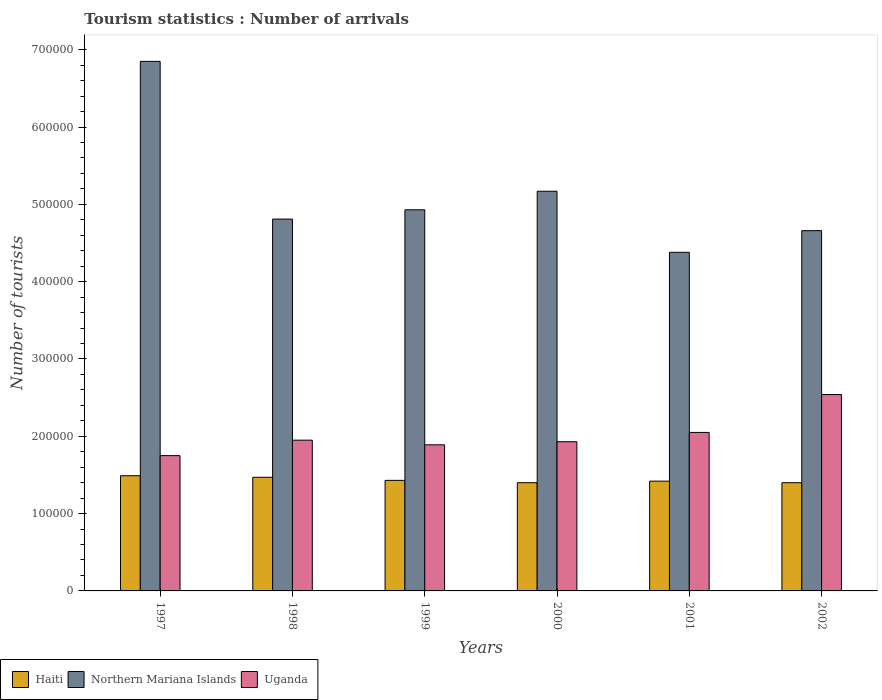How many different coloured bars are there?
Offer a terse response. 3. How many groups of bars are there?
Give a very brief answer. 6. Are the number of bars per tick equal to the number of legend labels?
Keep it short and to the point. Yes. How many bars are there on the 3rd tick from the left?
Ensure brevity in your answer.  3. What is the number of tourist arrivals in Haiti in 2001?
Provide a succinct answer. 1.42e+05. Across all years, what is the maximum number of tourist arrivals in Uganda?
Make the answer very short. 2.54e+05. Across all years, what is the minimum number of tourist arrivals in Northern Mariana Islands?
Your response must be concise. 4.38e+05. In which year was the number of tourist arrivals in Uganda maximum?
Offer a terse response. 2002. In which year was the number of tourist arrivals in Haiti minimum?
Make the answer very short. 2000. What is the total number of tourist arrivals in Haiti in the graph?
Offer a terse response. 8.61e+05. What is the difference between the number of tourist arrivals in Uganda in 1997 and that in 2000?
Ensure brevity in your answer.  -1.80e+04. What is the difference between the number of tourist arrivals in Haiti in 2001 and the number of tourist arrivals in Uganda in 1999?
Give a very brief answer. -4.70e+04. What is the average number of tourist arrivals in Northern Mariana Islands per year?
Your response must be concise. 5.13e+05. In the year 2001, what is the difference between the number of tourist arrivals in Haiti and number of tourist arrivals in Northern Mariana Islands?
Give a very brief answer. -2.96e+05. In how many years, is the number of tourist arrivals in Haiti greater than 40000?
Your answer should be very brief. 6. What is the difference between the highest and the lowest number of tourist arrivals in Haiti?
Make the answer very short. 9000. What does the 2nd bar from the left in 2002 represents?
Give a very brief answer. Northern Mariana Islands. What does the 2nd bar from the right in 2002 represents?
Make the answer very short. Northern Mariana Islands. Is it the case that in every year, the sum of the number of tourist arrivals in Haiti and number of tourist arrivals in Uganda is greater than the number of tourist arrivals in Northern Mariana Islands?
Provide a succinct answer. No. Are the values on the major ticks of Y-axis written in scientific E-notation?
Provide a short and direct response. No. Does the graph contain any zero values?
Keep it short and to the point. No. Does the graph contain grids?
Your answer should be compact. No. Where does the legend appear in the graph?
Give a very brief answer. Bottom left. How many legend labels are there?
Offer a terse response. 3. How are the legend labels stacked?
Keep it short and to the point. Horizontal. What is the title of the graph?
Make the answer very short. Tourism statistics : Number of arrivals. Does "Heavily indebted poor countries" appear as one of the legend labels in the graph?
Offer a terse response. No. What is the label or title of the X-axis?
Ensure brevity in your answer.  Years. What is the label or title of the Y-axis?
Offer a terse response. Number of tourists. What is the Number of tourists of Haiti in 1997?
Your answer should be compact. 1.49e+05. What is the Number of tourists of Northern Mariana Islands in 1997?
Provide a succinct answer. 6.85e+05. What is the Number of tourists of Uganda in 1997?
Keep it short and to the point. 1.75e+05. What is the Number of tourists in Haiti in 1998?
Give a very brief answer. 1.47e+05. What is the Number of tourists of Northern Mariana Islands in 1998?
Your answer should be very brief. 4.81e+05. What is the Number of tourists in Uganda in 1998?
Offer a terse response. 1.95e+05. What is the Number of tourists in Haiti in 1999?
Keep it short and to the point. 1.43e+05. What is the Number of tourists of Northern Mariana Islands in 1999?
Make the answer very short. 4.93e+05. What is the Number of tourists in Uganda in 1999?
Offer a terse response. 1.89e+05. What is the Number of tourists in Northern Mariana Islands in 2000?
Keep it short and to the point. 5.17e+05. What is the Number of tourists of Uganda in 2000?
Give a very brief answer. 1.93e+05. What is the Number of tourists of Haiti in 2001?
Offer a very short reply. 1.42e+05. What is the Number of tourists of Northern Mariana Islands in 2001?
Provide a succinct answer. 4.38e+05. What is the Number of tourists of Uganda in 2001?
Ensure brevity in your answer.  2.05e+05. What is the Number of tourists in Haiti in 2002?
Your response must be concise. 1.40e+05. What is the Number of tourists in Northern Mariana Islands in 2002?
Offer a very short reply. 4.66e+05. What is the Number of tourists in Uganda in 2002?
Ensure brevity in your answer.  2.54e+05. Across all years, what is the maximum Number of tourists in Haiti?
Offer a terse response. 1.49e+05. Across all years, what is the maximum Number of tourists in Northern Mariana Islands?
Your response must be concise. 6.85e+05. Across all years, what is the maximum Number of tourists of Uganda?
Your answer should be compact. 2.54e+05. Across all years, what is the minimum Number of tourists in Northern Mariana Islands?
Keep it short and to the point. 4.38e+05. Across all years, what is the minimum Number of tourists of Uganda?
Provide a short and direct response. 1.75e+05. What is the total Number of tourists of Haiti in the graph?
Give a very brief answer. 8.61e+05. What is the total Number of tourists of Northern Mariana Islands in the graph?
Give a very brief answer. 3.08e+06. What is the total Number of tourists of Uganda in the graph?
Make the answer very short. 1.21e+06. What is the difference between the Number of tourists of Northern Mariana Islands in 1997 and that in 1998?
Provide a succinct answer. 2.04e+05. What is the difference between the Number of tourists of Haiti in 1997 and that in 1999?
Keep it short and to the point. 6000. What is the difference between the Number of tourists in Northern Mariana Islands in 1997 and that in 1999?
Ensure brevity in your answer.  1.92e+05. What is the difference between the Number of tourists of Uganda in 1997 and that in 1999?
Make the answer very short. -1.40e+04. What is the difference between the Number of tourists of Haiti in 1997 and that in 2000?
Offer a very short reply. 9000. What is the difference between the Number of tourists of Northern Mariana Islands in 1997 and that in 2000?
Make the answer very short. 1.68e+05. What is the difference between the Number of tourists of Uganda in 1997 and that in 2000?
Offer a terse response. -1.80e+04. What is the difference between the Number of tourists of Haiti in 1997 and that in 2001?
Your answer should be very brief. 7000. What is the difference between the Number of tourists in Northern Mariana Islands in 1997 and that in 2001?
Offer a terse response. 2.47e+05. What is the difference between the Number of tourists in Uganda in 1997 and that in 2001?
Provide a succinct answer. -3.00e+04. What is the difference between the Number of tourists of Haiti in 1997 and that in 2002?
Provide a succinct answer. 9000. What is the difference between the Number of tourists in Northern Mariana Islands in 1997 and that in 2002?
Give a very brief answer. 2.19e+05. What is the difference between the Number of tourists in Uganda in 1997 and that in 2002?
Offer a very short reply. -7.90e+04. What is the difference between the Number of tourists in Haiti in 1998 and that in 1999?
Your answer should be compact. 4000. What is the difference between the Number of tourists in Northern Mariana Islands in 1998 and that in 1999?
Give a very brief answer. -1.20e+04. What is the difference between the Number of tourists of Uganda in 1998 and that in 1999?
Keep it short and to the point. 6000. What is the difference between the Number of tourists of Haiti in 1998 and that in 2000?
Offer a very short reply. 7000. What is the difference between the Number of tourists of Northern Mariana Islands in 1998 and that in 2000?
Provide a succinct answer. -3.60e+04. What is the difference between the Number of tourists in Uganda in 1998 and that in 2000?
Provide a short and direct response. 2000. What is the difference between the Number of tourists of Haiti in 1998 and that in 2001?
Provide a short and direct response. 5000. What is the difference between the Number of tourists in Northern Mariana Islands in 1998 and that in 2001?
Keep it short and to the point. 4.30e+04. What is the difference between the Number of tourists in Uganda in 1998 and that in 2001?
Ensure brevity in your answer.  -10000. What is the difference between the Number of tourists in Haiti in 1998 and that in 2002?
Provide a succinct answer. 7000. What is the difference between the Number of tourists in Northern Mariana Islands in 1998 and that in 2002?
Provide a succinct answer. 1.50e+04. What is the difference between the Number of tourists of Uganda in 1998 and that in 2002?
Ensure brevity in your answer.  -5.90e+04. What is the difference between the Number of tourists of Haiti in 1999 and that in 2000?
Your response must be concise. 3000. What is the difference between the Number of tourists in Northern Mariana Islands in 1999 and that in 2000?
Your answer should be very brief. -2.40e+04. What is the difference between the Number of tourists in Uganda in 1999 and that in 2000?
Your response must be concise. -4000. What is the difference between the Number of tourists in Haiti in 1999 and that in 2001?
Ensure brevity in your answer.  1000. What is the difference between the Number of tourists of Northern Mariana Islands in 1999 and that in 2001?
Ensure brevity in your answer.  5.50e+04. What is the difference between the Number of tourists in Uganda in 1999 and that in 2001?
Offer a very short reply. -1.60e+04. What is the difference between the Number of tourists in Haiti in 1999 and that in 2002?
Offer a terse response. 3000. What is the difference between the Number of tourists of Northern Mariana Islands in 1999 and that in 2002?
Provide a succinct answer. 2.70e+04. What is the difference between the Number of tourists of Uganda in 1999 and that in 2002?
Your response must be concise. -6.50e+04. What is the difference between the Number of tourists in Haiti in 2000 and that in 2001?
Keep it short and to the point. -2000. What is the difference between the Number of tourists of Northern Mariana Islands in 2000 and that in 2001?
Your answer should be very brief. 7.90e+04. What is the difference between the Number of tourists of Uganda in 2000 and that in 2001?
Ensure brevity in your answer.  -1.20e+04. What is the difference between the Number of tourists in Northern Mariana Islands in 2000 and that in 2002?
Provide a short and direct response. 5.10e+04. What is the difference between the Number of tourists of Uganda in 2000 and that in 2002?
Offer a terse response. -6.10e+04. What is the difference between the Number of tourists of Northern Mariana Islands in 2001 and that in 2002?
Ensure brevity in your answer.  -2.80e+04. What is the difference between the Number of tourists in Uganda in 2001 and that in 2002?
Ensure brevity in your answer.  -4.90e+04. What is the difference between the Number of tourists of Haiti in 1997 and the Number of tourists of Northern Mariana Islands in 1998?
Your answer should be compact. -3.32e+05. What is the difference between the Number of tourists in Haiti in 1997 and the Number of tourists in Uganda in 1998?
Offer a terse response. -4.60e+04. What is the difference between the Number of tourists in Northern Mariana Islands in 1997 and the Number of tourists in Uganda in 1998?
Offer a very short reply. 4.90e+05. What is the difference between the Number of tourists in Haiti in 1997 and the Number of tourists in Northern Mariana Islands in 1999?
Your answer should be compact. -3.44e+05. What is the difference between the Number of tourists in Haiti in 1997 and the Number of tourists in Uganda in 1999?
Make the answer very short. -4.00e+04. What is the difference between the Number of tourists in Northern Mariana Islands in 1997 and the Number of tourists in Uganda in 1999?
Your answer should be compact. 4.96e+05. What is the difference between the Number of tourists in Haiti in 1997 and the Number of tourists in Northern Mariana Islands in 2000?
Your response must be concise. -3.68e+05. What is the difference between the Number of tourists of Haiti in 1997 and the Number of tourists of Uganda in 2000?
Ensure brevity in your answer.  -4.40e+04. What is the difference between the Number of tourists in Northern Mariana Islands in 1997 and the Number of tourists in Uganda in 2000?
Your response must be concise. 4.92e+05. What is the difference between the Number of tourists in Haiti in 1997 and the Number of tourists in Northern Mariana Islands in 2001?
Ensure brevity in your answer.  -2.89e+05. What is the difference between the Number of tourists of Haiti in 1997 and the Number of tourists of Uganda in 2001?
Make the answer very short. -5.60e+04. What is the difference between the Number of tourists in Haiti in 1997 and the Number of tourists in Northern Mariana Islands in 2002?
Provide a succinct answer. -3.17e+05. What is the difference between the Number of tourists in Haiti in 1997 and the Number of tourists in Uganda in 2002?
Your answer should be very brief. -1.05e+05. What is the difference between the Number of tourists in Northern Mariana Islands in 1997 and the Number of tourists in Uganda in 2002?
Your answer should be compact. 4.31e+05. What is the difference between the Number of tourists in Haiti in 1998 and the Number of tourists in Northern Mariana Islands in 1999?
Provide a short and direct response. -3.46e+05. What is the difference between the Number of tourists of Haiti in 1998 and the Number of tourists of Uganda in 1999?
Your response must be concise. -4.20e+04. What is the difference between the Number of tourists in Northern Mariana Islands in 1998 and the Number of tourists in Uganda in 1999?
Provide a short and direct response. 2.92e+05. What is the difference between the Number of tourists of Haiti in 1998 and the Number of tourists of Northern Mariana Islands in 2000?
Give a very brief answer. -3.70e+05. What is the difference between the Number of tourists of Haiti in 1998 and the Number of tourists of Uganda in 2000?
Your answer should be very brief. -4.60e+04. What is the difference between the Number of tourists of Northern Mariana Islands in 1998 and the Number of tourists of Uganda in 2000?
Your answer should be compact. 2.88e+05. What is the difference between the Number of tourists in Haiti in 1998 and the Number of tourists in Northern Mariana Islands in 2001?
Give a very brief answer. -2.91e+05. What is the difference between the Number of tourists in Haiti in 1998 and the Number of tourists in Uganda in 2001?
Provide a short and direct response. -5.80e+04. What is the difference between the Number of tourists in Northern Mariana Islands in 1998 and the Number of tourists in Uganda in 2001?
Offer a very short reply. 2.76e+05. What is the difference between the Number of tourists in Haiti in 1998 and the Number of tourists in Northern Mariana Islands in 2002?
Make the answer very short. -3.19e+05. What is the difference between the Number of tourists of Haiti in 1998 and the Number of tourists of Uganda in 2002?
Your response must be concise. -1.07e+05. What is the difference between the Number of tourists in Northern Mariana Islands in 1998 and the Number of tourists in Uganda in 2002?
Your answer should be very brief. 2.27e+05. What is the difference between the Number of tourists of Haiti in 1999 and the Number of tourists of Northern Mariana Islands in 2000?
Ensure brevity in your answer.  -3.74e+05. What is the difference between the Number of tourists of Haiti in 1999 and the Number of tourists of Uganda in 2000?
Your answer should be compact. -5.00e+04. What is the difference between the Number of tourists in Northern Mariana Islands in 1999 and the Number of tourists in Uganda in 2000?
Provide a succinct answer. 3.00e+05. What is the difference between the Number of tourists of Haiti in 1999 and the Number of tourists of Northern Mariana Islands in 2001?
Your answer should be very brief. -2.95e+05. What is the difference between the Number of tourists of Haiti in 1999 and the Number of tourists of Uganda in 2001?
Give a very brief answer. -6.20e+04. What is the difference between the Number of tourists in Northern Mariana Islands in 1999 and the Number of tourists in Uganda in 2001?
Keep it short and to the point. 2.88e+05. What is the difference between the Number of tourists of Haiti in 1999 and the Number of tourists of Northern Mariana Islands in 2002?
Ensure brevity in your answer.  -3.23e+05. What is the difference between the Number of tourists in Haiti in 1999 and the Number of tourists in Uganda in 2002?
Offer a terse response. -1.11e+05. What is the difference between the Number of tourists of Northern Mariana Islands in 1999 and the Number of tourists of Uganda in 2002?
Give a very brief answer. 2.39e+05. What is the difference between the Number of tourists of Haiti in 2000 and the Number of tourists of Northern Mariana Islands in 2001?
Keep it short and to the point. -2.98e+05. What is the difference between the Number of tourists in Haiti in 2000 and the Number of tourists in Uganda in 2001?
Offer a terse response. -6.50e+04. What is the difference between the Number of tourists of Northern Mariana Islands in 2000 and the Number of tourists of Uganda in 2001?
Ensure brevity in your answer.  3.12e+05. What is the difference between the Number of tourists of Haiti in 2000 and the Number of tourists of Northern Mariana Islands in 2002?
Offer a terse response. -3.26e+05. What is the difference between the Number of tourists in Haiti in 2000 and the Number of tourists in Uganda in 2002?
Keep it short and to the point. -1.14e+05. What is the difference between the Number of tourists of Northern Mariana Islands in 2000 and the Number of tourists of Uganda in 2002?
Provide a succinct answer. 2.63e+05. What is the difference between the Number of tourists in Haiti in 2001 and the Number of tourists in Northern Mariana Islands in 2002?
Provide a short and direct response. -3.24e+05. What is the difference between the Number of tourists of Haiti in 2001 and the Number of tourists of Uganda in 2002?
Your answer should be very brief. -1.12e+05. What is the difference between the Number of tourists in Northern Mariana Islands in 2001 and the Number of tourists in Uganda in 2002?
Keep it short and to the point. 1.84e+05. What is the average Number of tourists in Haiti per year?
Provide a succinct answer. 1.44e+05. What is the average Number of tourists in Northern Mariana Islands per year?
Provide a short and direct response. 5.13e+05. What is the average Number of tourists of Uganda per year?
Keep it short and to the point. 2.02e+05. In the year 1997, what is the difference between the Number of tourists in Haiti and Number of tourists in Northern Mariana Islands?
Keep it short and to the point. -5.36e+05. In the year 1997, what is the difference between the Number of tourists of Haiti and Number of tourists of Uganda?
Provide a succinct answer. -2.60e+04. In the year 1997, what is the difference between the Number of tourists of Northern Mariana Islands and Number of tourists of Uganda?
Offer a terse response. 5.10e+05. In the year 1998, what is the difference between the Number of tourists in Haiti and Number of tourists in Northern Mariana Islands?
Keep it short and to the point. -3.34e+05. In the year 1998, what is the difference between the Number of tourists of Haiti and Number of tourists of Uganda?
Make the answer very short. -4.80e+04. In the year 1998, what is the difference between the Number of tourists in Northern Mariana Islands and Number of tourists in Uganda?
Your answer should be very brief. 2.86e+05. In the year 1999, what is the difference between the Number of tourists of Haiti and Number of tourists of Northern Mariana Islands?
Provide a succinct answer. -3.50e+05. In the year 1999, what is the difference between the Number of tourists in Haiti and Number of tourists in Uganda?
Give a very brief answer. -4.60e+04. In the year 1999, what is the difference between the Number of tourists of Northern Mariana Islands and Number of tourists of Uganda?
Ensure brevity in your answer.  3.04e+05. In the year 2000, what is the difference between the Number of tourists in Haiti and Number of tourists in Northern Mariana Islands?
Provide a short and direct response. -3.77e+05. In the year 2000, what is the difference between the Number of tourists in Haiti and Number of tourists in Uganda?
Your answer should be very brief. -5.30e+04. In the year 2000, what is the difference between the Number of tourists of Northern Mariana Islands and Number of tourists of Uganda?
Your response must be concise. 3.24e+05. In the year 2001, what is the difference between the Number of tourists of Haiti and Number of tourists of Northern Mariana Islands?
Give a very brief answer. -2.96e+05. In the year 2001, what is the difference between the Number of tourists in Haiti and Number of tourists in Uganda?
Offer a terse response. -6.30e+04. In the year 2001, what is the difference between the Number of tourists of Northern Mariana Islands and Number of tourists of Uganda?
Your answer should be compact. 2.33e+05. In the year 2002, what is the difference between the Number of tourists of Haiti and Number of tourists of Northern Mariana Islands?
Your answer should be compact. -3.26e+05. In the year 2002, what is the difference between the Number of tourists in Haiti and Number of tourists in Uganda?
Give a very brief answer. -1.14e+05. In the year 2002, what is the difference between the Number of tourists in Northern Mariana Islands and Number of tourists in Uganda?
Provide a succinct answer. 2.12e+05. What is the ratio of the Number of tourists in Haiti in 1997 to that in 1998?
Offer a very short reply. 1.01. What is the ratio of the Number of tourists of Northern Mariana Islands in 1997 to that in 1998?
Your answer should be very brief. 1.42. What is the ratio of the Number of tourists in Uganda in 1997 to that in 1998?
Provide a short and direct response. 0.9. What is the ratio of the Number of tourists of Haiti in 1997 to that in 1999?
Keep it short and to the point. 1.04. What is the ratio of the Number of tourists of Northern Mariana Islands in 1997 to that in 1999?
Provide a short and direct response. 1.39. What is the ratio of the Number of tourists of Uganda in 1997 to that in 1999?
Your response must be concise. 0.93. What is the ratio of the Number of tourists in Haiti in 1997 to that in 2000?
Your answer should be compact. 1.06. What is the ratio of the Number of tourists of Northern Mariana Islands in 1997 to that in 2000?
Offer a terse response. 1.32. What is the ratio of the Number of tourists of Uganda in 1997 to that in 2000?
Your answer should be very brief. 0.91. What is the ratio of the Number of tourists of Haiti in 1997 to that in 2001?
Offer a very short reply. 1.05. What is the ratio of the Number of tourists in Northern Mariana Islands in 1997 to that in 2001?
Provide a short and direct response. 1.56. What is the ratio of the Number of tourists in Uganda in 1997 to that in 2001?
Your response must be concise. 0.85. What is the ratio of the Number of tourists of Haiti in 1997 to that in 2002?
Your answer should be compact. 1.06. What is the ratio of the Number of tourists in Northern Mariana Islands in 1997 to that in 2002?
Your response must be concise. 1.47. What is the ratio of the Number of tourists of Uganda in 1997 to that in 2002?
Ensure brevity in your answer.  0.69. What is the ratio of the Number of tourists of Haiti in 1998 to that in 1999?
Ensure brevity in your answer.  1.03. What is the ratio of the Number of tourists in Northern Mariana Islands in 1998 to that in 1999?
Provide a short and direct response. 0.98. What is the ratio of the Number of tourists in Uganda in 1998 to that in 1999?
Make the answer very short. 1.03. What is the ratio of the Number of tourists in Northern Mariana Islands in 1998 to that in 2000?
Your answer should be compact. 0.93. What is the ratio of the Number of tourists in Uganda in 1998 to that in 2000?
Your response must be concise. 1.01. What is the ratio of the Number of tourists in Haiti in 1998 to that in 2001?
Offer a very short reply. 1.04. What is the ratio of the Number of tourists in Northern Mariana Islands in 1998 to that in 2001?
Ensure brevity in your answer.  1.1. What is the ratio of the Number of tourists of Uganda in 1998 to that in 2001?
Provide a succinct answer. 0.95. What is the ratio of the Number of tourists in Northern Mariana Islands in 1998 to that in 2002?
Offer a very short reply. 1.03. What is the ratio of the Number of tourists of Uganda in 1998 to that in 2002?
Ensure brevity in your answer.  0.77. What is the ratio of the Number of tourists in Haiti in 1999 to that in 2000?
Make the answer very short. 1.02. What is the ratio of the Number of tourists in Northern Mariana Islands in 1999 to that in 2000?
Provide a short and direct response. 0.95. What is the ratio of the Number of tourists in Uganda in 1999 to that in 2000?
Offer a terse response. 0.98. What is the ratio of the Number of tourists in Haiti in 1999 to that in 2001?
Offer a terse response. 1.01. What is the ratio of the Number of tourists of Northern Mariana Islands in 1999 to that in 2001?
Provide a short and direct response. 1.13. What is the ratio of the Number of tourists of Uganda in 1999 to that in 2001?
Offer a terse response. 0.92. What is the ratio of the Number of tourists in Haiti in 1999 to that in 2002?
Provide a short and direct response. 1.02. What is the ratio of the Number of tourists in Northern Mariana Islands in 1999 to that in 2002?
Make the answer very short. 1.06. What is the ratio of the Number of tourists in Uganda in 1999 to that in 2002?
Offer a very short reply. 0.74. What is the ratio of the Number of tourists of Haiti in 2000 to that in 2001?
Your answer should be compact. 0.99. What is the ratio of the Number of tourists in Northern Mariana Islands in 2000 to that in 2001?
Provide a short and direct response. 1.18. What is the ratio of the Number of tourists of Uganda in 2000 to that in 2001?
Make the answer very short. 0.94. What is the ratio of the Number of tourists in Northern Mariana Islands in 2000 to that in 2002?
Provide a succinct answer. 1.11. What is the ratio of the Number of tourists in Uganda in 2000 to that in 2002?
Provide a short and direct response. 0.76. What is the ratio of the Number of tourists in Haiti in 2001 to that in 2002?
Offer a terse response. 1.01. What is the ratio of the Number of tourists in Northern Mariana Islands in 2001 to that in 2002?
Offer a very short reply. 0.94. What is the ratio of the Number of tourists of Uganda in 2001 to that in 2002?
Offer a very short reply. 0.81. What is the difference between the highest and the second highest Number of tourists of Northern Mariana Islands?
Provide a short and direct response. 1.68e+05. What is the difference between the highest and the second highest Number of tourists of Uganda?
Ensure brevity in your answer.  4.90e+04. What is the difference between the highest and the lowest Number of tourists in Haiti?
Offer a terse response. 9000. What is the difference between the highest and the lowest Number of tourists in Northern Mariana Islands?
Your answer should be very brief. 2.47e+05. What is the difference between the highest and the lowest Number of tourists in Uganda?
Your answer should be compact. 7.90e+04. 